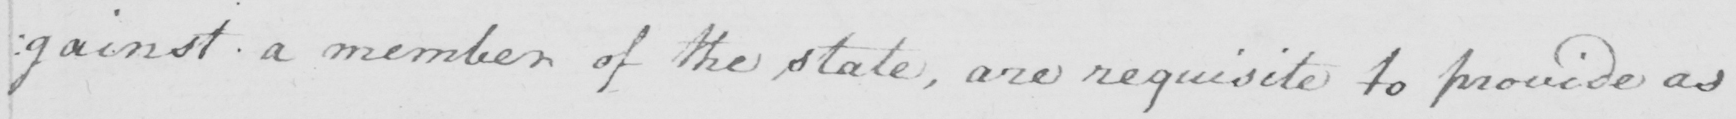What text is written in this handwritten line? : gainst a member of the state , are requisite to provide as 